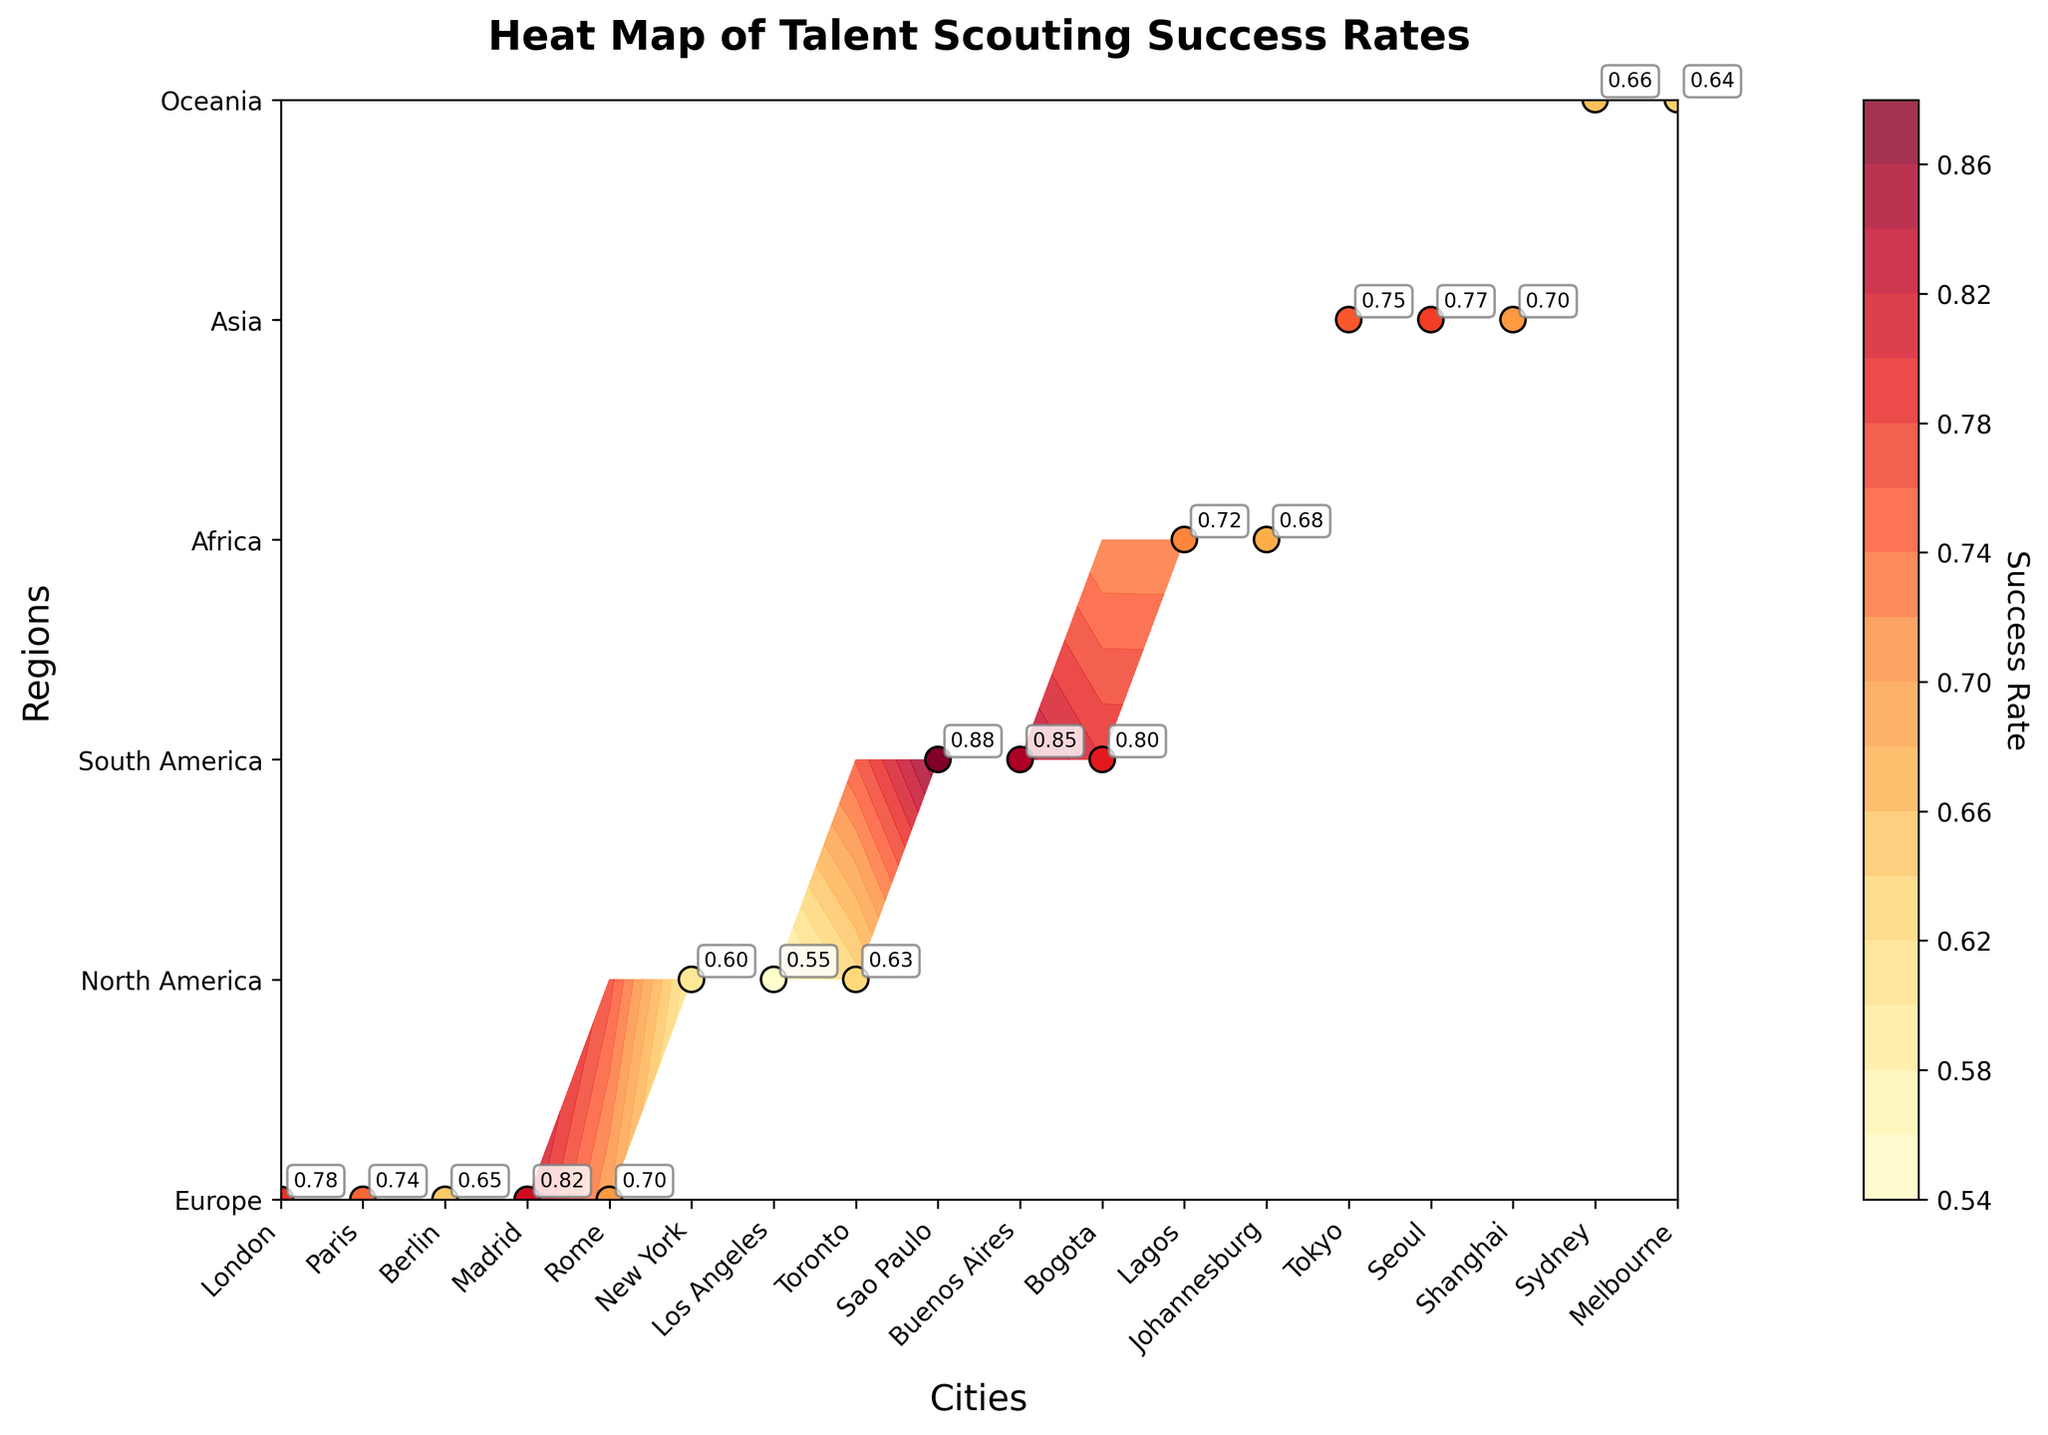What's the title of the plot? The title is located at the top of the plot. It summarizes the overall information represented in the figure.
Answer: Heat Map of Talent Scouting Success Rates What regions are compared in the plot? The regions are indicated on the y-axis of the plot. Each region represents a category along this axis.
Answer: Europe, North America, South America, Africa, Asia, Oceania Which city has the highest talent scouting success rate? The cities with higher success rates are depicted in warmer colors on the plot. The exact values are also labeled near the data points.
Answer: Sao Paulo How does the success rate of New York compare to that of Sydney? By examining their respective positions on the plot and reading the annotated values, we can directly compare the success rates of New York and Sydney.
Answer: New York has a success rate of 0.60, while Sydney has a success rate of 0.66 What's the difference in success rates between Madrid and Berlin? Find the success rate values for both cities from their annotations on the plot, then subtract Berlin's rate from Madrid's rate.
Answer: 0.82 (Madrid) - 0.65 (Berlin) = 0.17 Are there any regions where the cities have a similar success rate? By looking at the annotated values clustered within each region, we assess how close the values are to each other.
Answer: Asia (Tokyo 0.75, Seoul 0.77, Shanghai 0.70) Which city in Europe has the lowest scouting success rate? Identify the Europe section on the y-axis, then observe which city has the lowest annotated value in that section.
Answer: Berlin What is the range of success rates in South America? Check the annotated success rates of the cities in South America, then find the difference between the highest and lowest values.
Answer: Range = 0.88 (Sao Paulo) - 0.80 (Bogota) = 0.08 Is there a visible trend in success rates across different continents? Look for patterns in color distribution across different regions and compare the success rates annotated for each continent.
Answer: Yes, South America tends to have higher success rates compared to North America and Oceania Which city has a similar success rate to Tokyo in any other region? Locate Tokyo's success rate on the plot, then compare it against annotated values in other regions. Look for a city with a rate close to Tokyo's 0.75.
Answer: Seoul (0.77) 